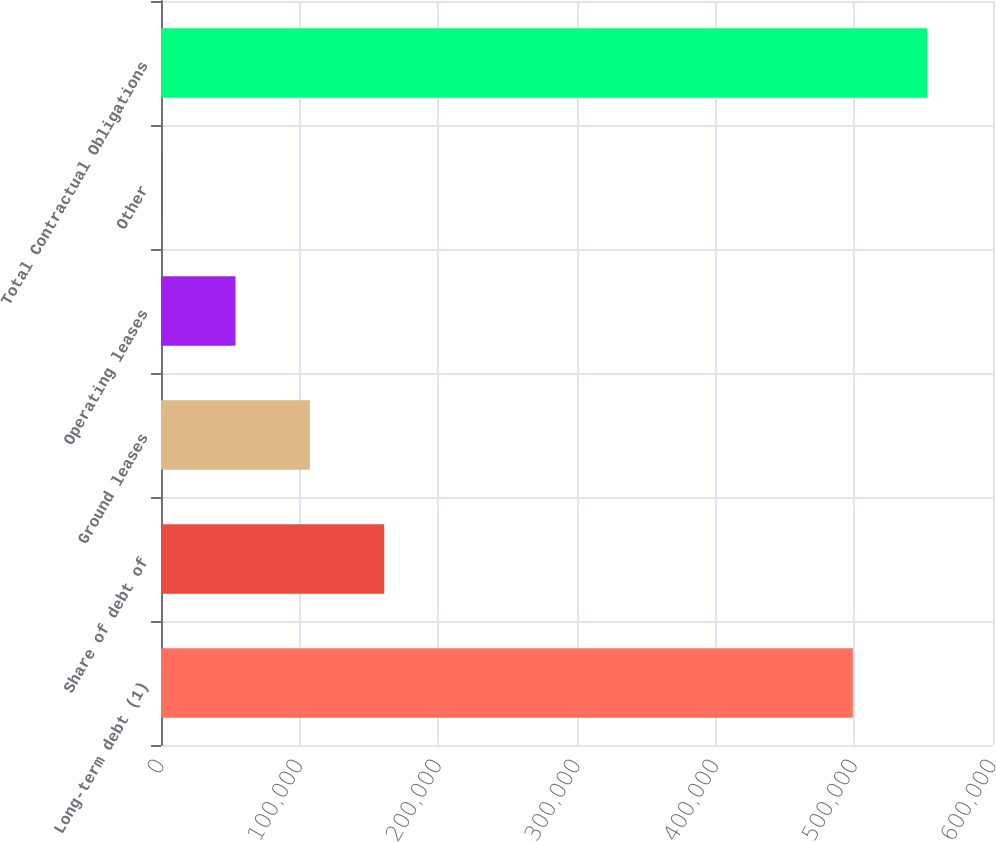<chart> <loc_0><loc_0><loc_500><loc_500><bar_chart><fcel>Long-term debt (1)<fcel>Share of debt of<fcel>Ground leases<fcel>Operating leases<fcel>Other<fcel>Total Contractual Obligations<nl><fcel>498912<fcel>160991<fcel>107358<fcel>53723.8<fcel>90<fcel>552546<nl></chart> 